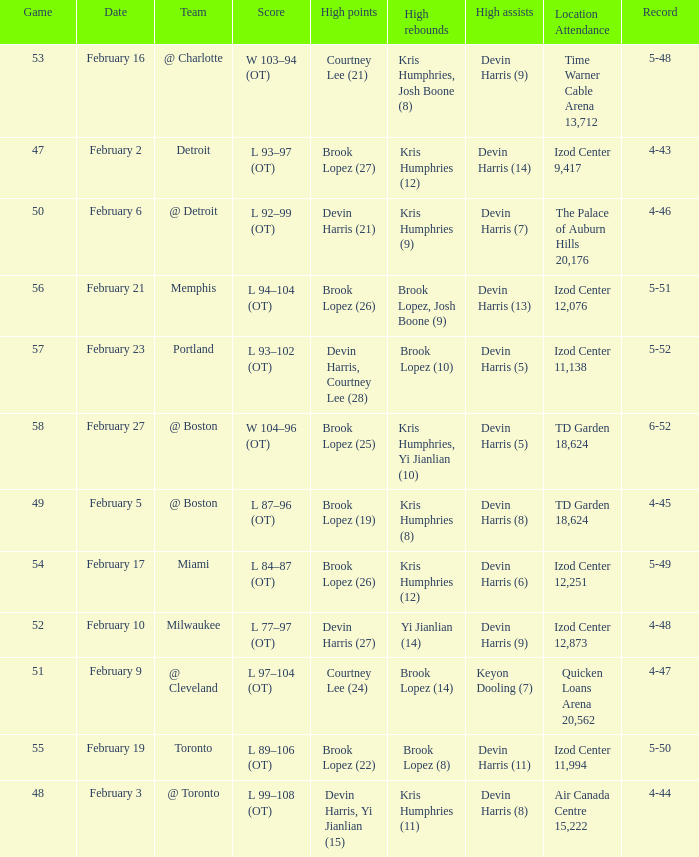What's the highest game number for a game in which Kris Humphries (8) did the high rebounds? 49.0. 